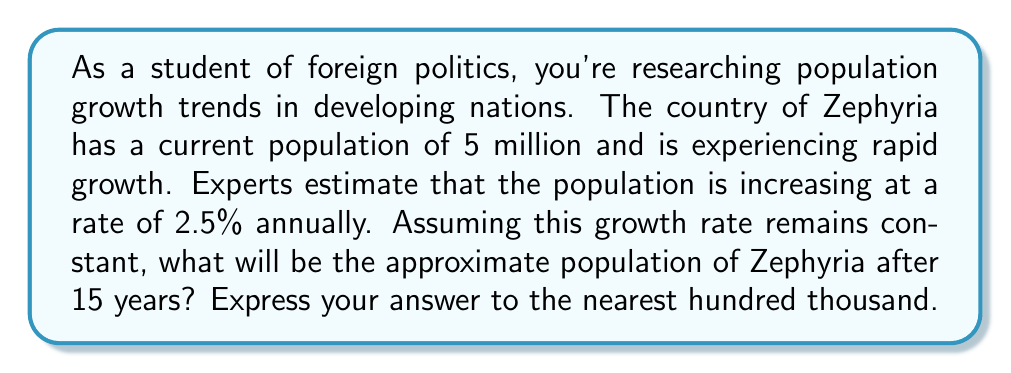Give your solution to this math problem. Let's approach this step-by-step using an exponential growth model:

1) The exponential growth formula is:
   $A = P(1 + r)^t$
   Where:
   $A$ = Final amount
   $P$ = Initial principal balance
   $r$ = Growth rate (as a decimal)
   $t$ = Time period

2) We know:
   $P = 5,000,000$ (initial population)
   $r = 0.025$ (2.5% expressed as a decimal)
   $t = 15$ years

3) Let's plug these values into our formula:
   $A = 5,000,000(1 + 0.025)^{15}$

4) Simplify inside the parentheses:
   $A = 5,000,000(1.025)^{15}$

5) Now, let's calculate $(1.025)^{15}$:
   $(1.025)^{15} \approx 1.4463$ (rounded to 4 decimal places)

6) Multiply this by the initial population:
   $A = 5,000,000 \times 1.4463 = 7,231,500$

7) Rounding to the nearest hundred thousand:
   $7,231,500 \approx 7,200,000$

Therefore, after 15 years, the population of Zephyria will be approximately 7,200,000.
Answer: 7,200,000 